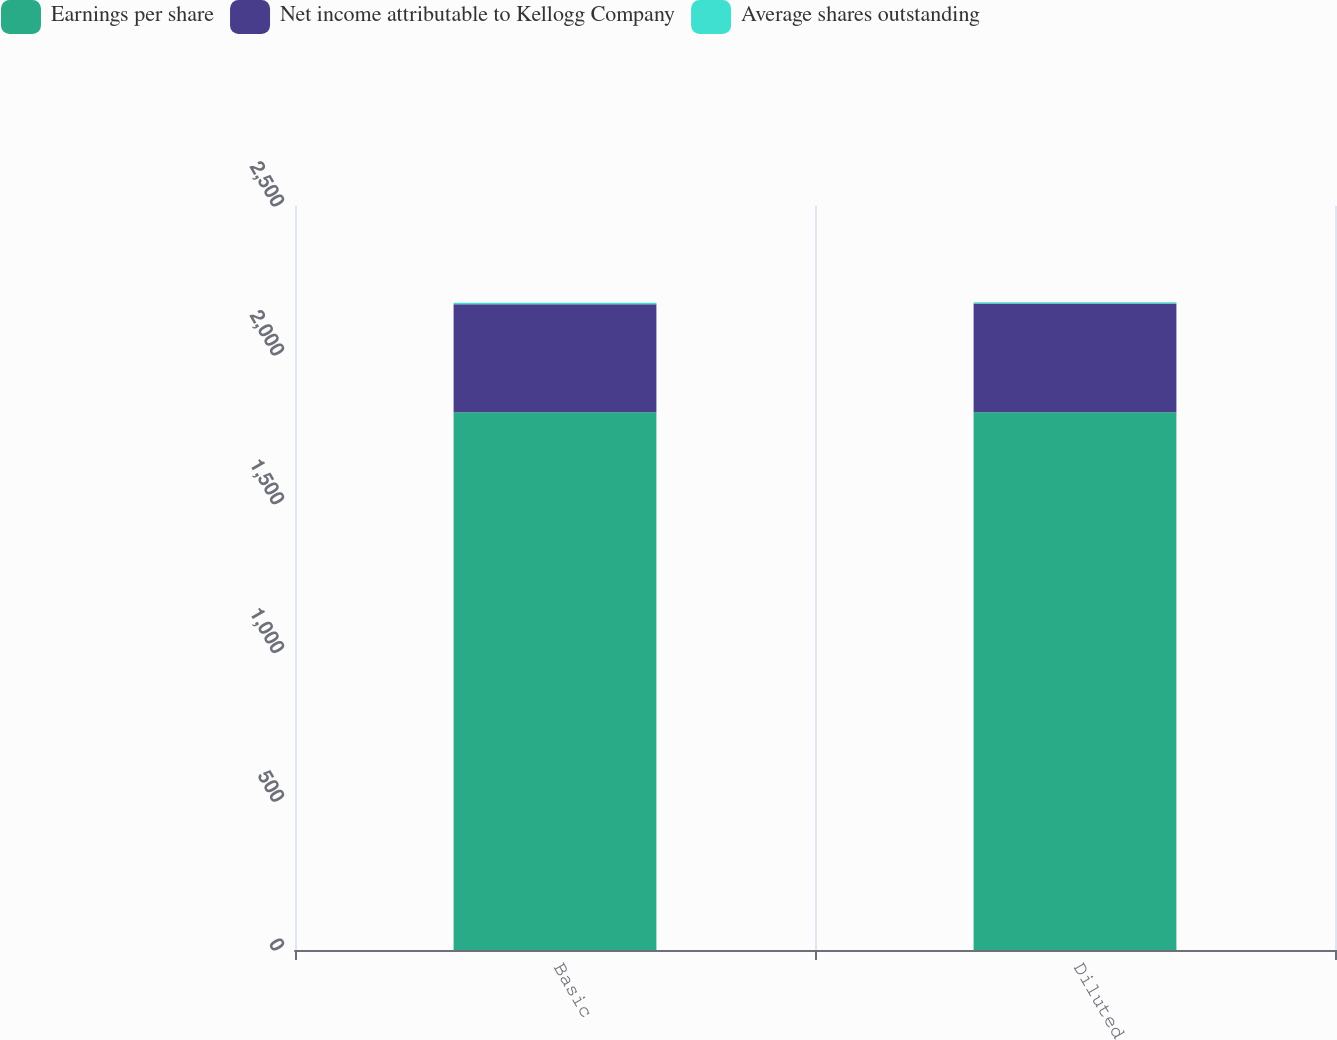Convert chart. <chart><loc_0><loc_0><loc_500><loc_500><stacked_bar_chart><ecel><fcel>Basic<fcel>Diluted<nl><fcel>Earnings per share<fcel>1807<fcel>1807<nl><fcel>Net income attributable to Kellogg Company<fcel>363<fcel>365<nl><fcel>Average shares outstanding<fcel>4.98<fcel>4.94<nl></chart> 